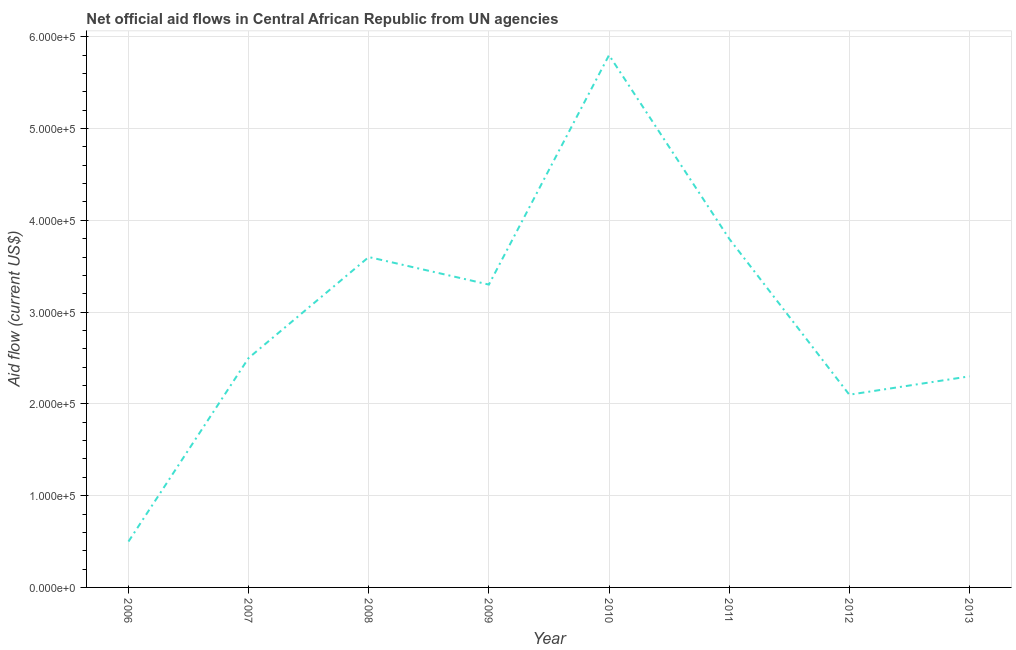What is the net official flows from un agencies in 2010?
Your answer should be compact. 5.80e+05. Across all years, what is the maximum net official flows from un agencies?
Your answer should be compact. 5.80e+05. Across all years, what is the minimum net official flows from un agencies?
Provide a succinct answer. 5.00e+04. What is the sum of the net official flows from un agencies?
Offer a very short reply. 2.39e+06. What is the difference between the net official flows from un agencies in 2008 and 2009?
Keep it short and to the point. 3.00e+04. What is the average net official flows from un agencies per year?
Ensure brevity in your answer.  2.99e+05. What is the ratio of the net official flows from un agencies in 2012 to that in 2013?
Your answer should be compact. 0.91. Is the net official flows from un agencies in 2006 less than that in 2012?
Make the answer very short. Yes. Is the difference between the net official flows from un agencies in 2008 and 2013 greater than the difference between any two years?
Offer a terse response. No. Is the sum of the net official flows from un agencies in 2006 and 2011 greater than the maximum net official flows from un agencies across all years?
Make the answer very short. No. What is the difference between the highest and the lowest net official flows from un agencies?
Your answer should be very brief. 5.30e+05. How many years are there in the graph?
Offer a terse response. 8. What is the difference between two consecutive major ticks on the Y-axis?
Give a very brief answer. 1.00e+05. Are the values on the major ticks of Y-axis written in scientific E-notation?
Offer a terse response. Yes. Does the graph contain any zero values?
Provide a succinct answer. No. Does the graph contain grids?
Keep it short and to the point. Yes. What is the title of the graph?
Ensure brevity in your answer.  Net official aid flows in Central African Republic from UN agencies. What is the label or title of the Y-axis?
Make the answer very short. Aid flow (current US$). What is the Aid flow (current US$) in 2009?
Your answer should be very brief. 3.30e+05. What is the Aid flow (current US$) in 2010?
Keep it short and to the point. 5.80e+05. What is the Aid flow (current US$) of 2012?
Your answer should be very brief. 2.10e+05. What is the Aid flow (current US$) of 2013?
Offer a very short reply. 2.30e+05. What is the difference between the Aid flow (current US$) in 2006 and 2007?
Ensure brevity in your answer.  -2.00e+05. What is the difference between the Aid flow (current US$) in 2006 and 2008?
Ensure brevity in your answer.  -3.10e+05. What is the difference between the Aid flow (current US$) in 2006 and 2009?
Make the answer very short. -2.80e+05. What is the difference between the Aid flow (current US$) in 2006 and 2010?
Provide a succinct answer. -5.30e+05. What is the difference between the Aid flow (current US$) in 2006 and 2011?
Ensure brevity in your answer.  -3.30e+05. What is the difference between the Aid flow (current US$) in 2006 and 2012?
Your answer should be very brief. -1.60e+05. What is the difference between the Aid flow (current US$) in 2006 and 2013?
Make the answer very short. -1.80e+05. What is the difference between the Aid flow (current US$) in 2007 and 2009?
Your answer should be very brief. -8.00e+04. What is the difference between the Aid flow (current US$) in 2007 and 2010?
Your response must be concise. -3.30e+05. What is the difference between the Aid flow (current US$) in 2007 and 2012?
Your answer should be very brief. 4.00e+04. What is the difference between the Aid flow (current US$) in 2007 and 2013?
Keep it short and to the point. 2.00e+04. What is the difference between the Aid flow (current US$) in 2008 and 2009?
Provide a short and direct response. 3.00e+04. What is the difference between the Aid flow (current US$) in 2008 and 2011?
Your answer should be very brief. -2.00e+04. What is the difference between the Aid flow (current US$) in 2008 and 2013?
Offer a terse response. 1.30e+05. What is the difference between the Aid flow (current US$) in 2009 and 2013?
Offer a terse response. 1.00e+05. What is the difference between the Aid flow (current US$) in 2010 and 2012?
Your answer should be very brief. 3.70e+05. What is the difference between the Aid flow (current US$) in 2011 and 2013?
Offer a very short reply. 1.50e+05. What is the ratio of the Aid flow (current US$) in 2006 to that in 2007?
Offer a very short reply. 0.2. What is the ratio of the Aid flow (current US$) in 2006 to that in 2008?
Give a very brief answer. 0.14. What is the ratio of the Aid flow (current US$) in 2006 to that in 2009?
Your answer should be very brief. 0.15. What is the ratio of the Aid flow (current US$) in 2006 to that in 2010?
Provide a short and direct response. 0.09. What is the ratio of the Aid flow (current US$) in 2006 to that in 2011?
Keep it short and to the point. 0.13. What is the ratio of the Aid flow (current US$) in 2006 to that in 2012?
Your response must be concise. 0.24. What is the ratio of the Aid flow (current US$) in 2006 to that in 2013?
Your response must be concise. 0.22. What is the ratio of the Aid flow (current US$) in 2007 to that in 2008?
Your answer should be compact. 0.69. What is the ratio of the Aid flow (current US$) in 2007 to that in 2009?
Make the answer very short. 0.76. What is the ratio of the Aid flow (current US$) in 2007 to that in 2010?
Offer a terse response. 0.43. What is the ratio of the Aid flow (current US$) in 2007 to that in 2011?
Your answer should be very brief. 0.66. What is the ratio of the Aid flow (current US$) in 2007 to that in 2012?
Your answer should be very brief. 1.19. What is the ratio of the Aid flow (current US$) in 2007 to that in 2013?
Offer a very short reply. 1.09. What is the ratio of the Aid flow (current US$) in 2008 to that in 2009?
Your response must be concise. 1.09. What is the ratio of the Aid flow (current US$) in 2008 to that in 2010?
Your answer should be compact. 0.62. What is the ratio of the Aid flow (current US$) in 2008 to that in 2011?
Make the answer very short. 0.95. What is the ratio of the Aid flow (current US$) in 2008 to that in 2012?
Provide a succinct answer. 1.71. What is the ratio of the Aid flow (current US$) in 2008 to that in 2013?
Offer a very short reply. 1.56. What is the ratio of the Aid flow (current US$) in 2009 to that in 2010?
Keep it short and to the point. 0.57. What is the ratio of the Aid flow (current US$) in 2009 to that in 2011?
Your answer should be compact. 0.87. What is the ratio of the Aid flow (current US$) in 2009 to that in 2012?
Offer a terse response. 1.57. What is the ratio of the Aid flow (current US$) in 2009 to that in 2013?
Provide a short and direct response. 1.44. What is the ratio of the Aid flow (current US$) in 2010 to that in 2011?
Offer a terse response. 1.53. What is the ratio of the Aid flow (current US$) in 2010 to that in 2012?
Your answer should be very brief. 2.76. What is the ratio of the Aid flow (current US$) in 2010 to that in 2013?
Your response must be concise. 2.52. What is the ratio of the Aid flow (current US$) in 2011 to that in 2012?
Make the answer very short. 1.81. What is the ratio of the Aid flow (current US$) in 2011 to that in 2013?
Your answer should be very brief. 1.65. 